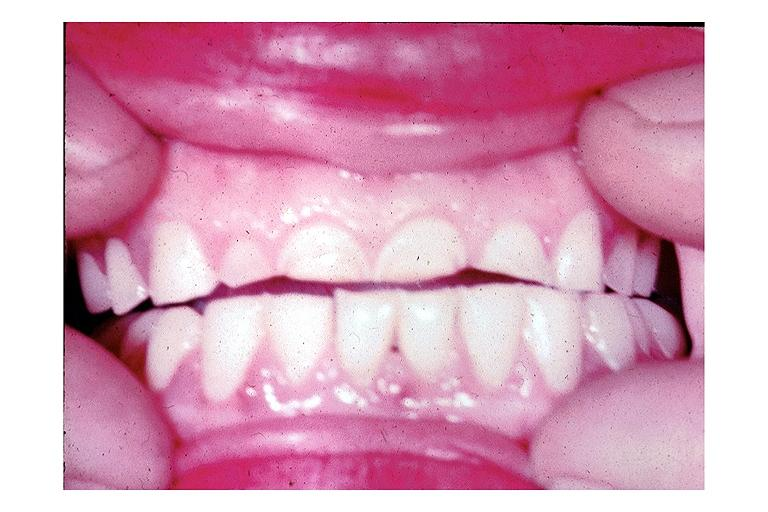where is this?
Answer the question using a single word or phrase. Oral 